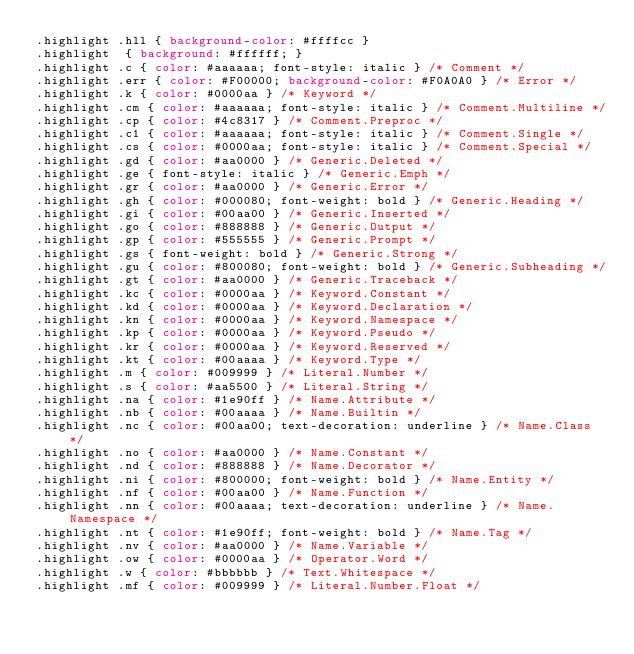Convert code to text. <code><loc_0><loc_0><loc_500><loc_500><_CSS_>.highlight .hll { background-color: #ffffcc }
.highlight  { background: #ffffff; }
.highlight .c { color: #aaaaaa; font-style: italic } /* Comment */
.highlight .err { color: #F00000; background-color: #F0A0A0 } /* Error */
.highlight .k { color: #0000aa } /* Keyword */
.highlight .cm { color: #aaaaaa; font-style: italic } /* Comment.Multiline */
.highlight .cp { color: #4c8317 } /* Comment.Preproc */
.highlight .c1 { color: #aaaaaa; font-style: italic } /* Comment.Single */
.highlight .cs { color: #0000aa; font-style: italic } /* Comment.Special */
.highlight .gd { color: #aa0000 } /* Generic.Deleted */
.highlight .ge { font-style: italic } /* Generic.Emph */
.highlight .gr { color: #aa0000 } /* Generic.Error */
.highlight .gh { color: #000080; font-weight: bold } /* Generic.Heading */
.highlight .gi { color: #00aa00 } /* Generic.Inserted */
.highlight .go { color: #888888 } /* Generic.Output */
.highlight .gp { color: #555555 } /* Generic.Prompt */
.highlight .gs { font-weight: bold } /* Generic.Strong */
.highlight .gu { color: #800080; font-weight: bold } /* Generic.Subheading */
.highlight .gt { color: #aa0000 } /* Generic.Traceback */
.highlight .kc { color: #0000aa } /* Keyword.Constant */
.highlight .kd { color: #0000aa } /* Keyword.Declaration */
.highlight .kn { color: #0000aa } /* Keyword.Namespace */
.highlight .kp { color: #0000aa } /* Keyword.Pseudo */
.highlight .kr { color: #0000aa } /* Keyword.Reserved */
.highlight .kt { color: #00aaaa } /* Keyword.Type */
.highlight .m { color: #009999 } /* Literal.Number */
.highlight .s { color: #aa5500 } /* Literal.String */
.highlight .na { color: #1e90ff } /* Name.Attribute */
.highlight .nb { color: #00aaaa } /* Name.Builtin */
.highlight .nc { color: #00aa00; text-decoration: underline } /* Name.Class */
.highlight .no { color: #aa0000 } /* Name.Constant */
.highlight .nd { color: #888888 } /* Name.Decorator */
.highlight .ni { color: #800000; font-weight: bold } /* Name.Entity */
.highlight .nf { color: #00aa00 } /* Name.Function */
.highlight .nn { color: #00aaaa; text-decoration: underline } /* Name.Namespace */
.highlight .nt { color: #1e90ff; font-weight: bold } /* Name.Tag */
.highlight .nv { color: #aa0000 } /* Name.Variable */
.highlight .ow { color: #0000aa } /* Operator.Word */
.highlight .w { color: #bbbbbb } /* Text.Whitespace */
.highlight .mf { color: #009999 } /* Literal.Number.Float */</code> 